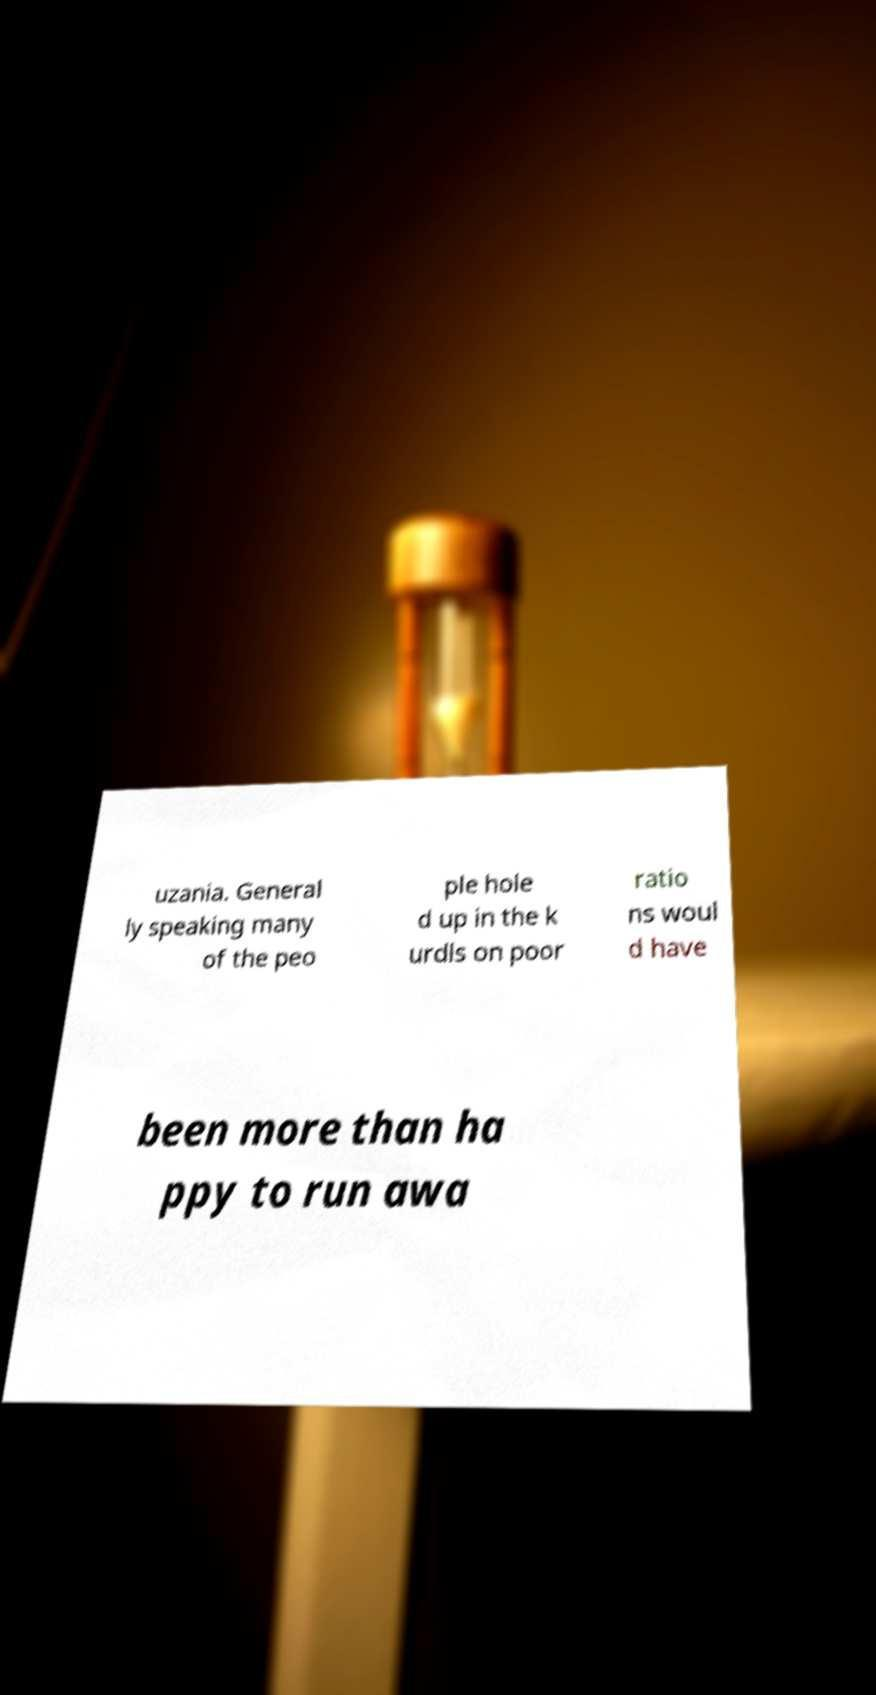Could you extract and type out the text from this image? uzania. General ly speaking many of the peo ple hole d up in the k urdls on poor ratio ns woul d have been more than ha ppy to run awa 